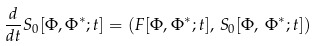Convert formula to latex. <formula><loc_0><loc_0><loc_500><loc_500>\frac { d } { d t } S _ { 0 } [ \Phi , \Phi ^ { * } ; t ] = \left ( F [ \Phi , \Phi ^ { * } ; t ] , \, S _ { 0 } [ \Phi , \, \Phi ^ { * } ; t ] \right )</formula> 